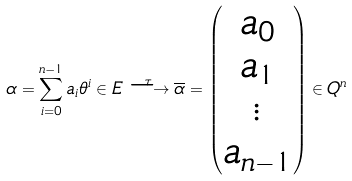Convert formula to latex. <formula><loc_0><loc_0><loc_500><loc_500>\alpha = \sum _ { i = 0 } ^ { n - 1 } a _ { i } \theta ^ { i } \in E \stackrel { \tau } { \longrightarrow } \overline { \alpha } = \begin{pmatrix} a _ { 0 } \\ a _ { 1 } \\ \vdots \\ a _ { n - 1 } \end{pmatrix} \in Q ^ { n }</formula> 